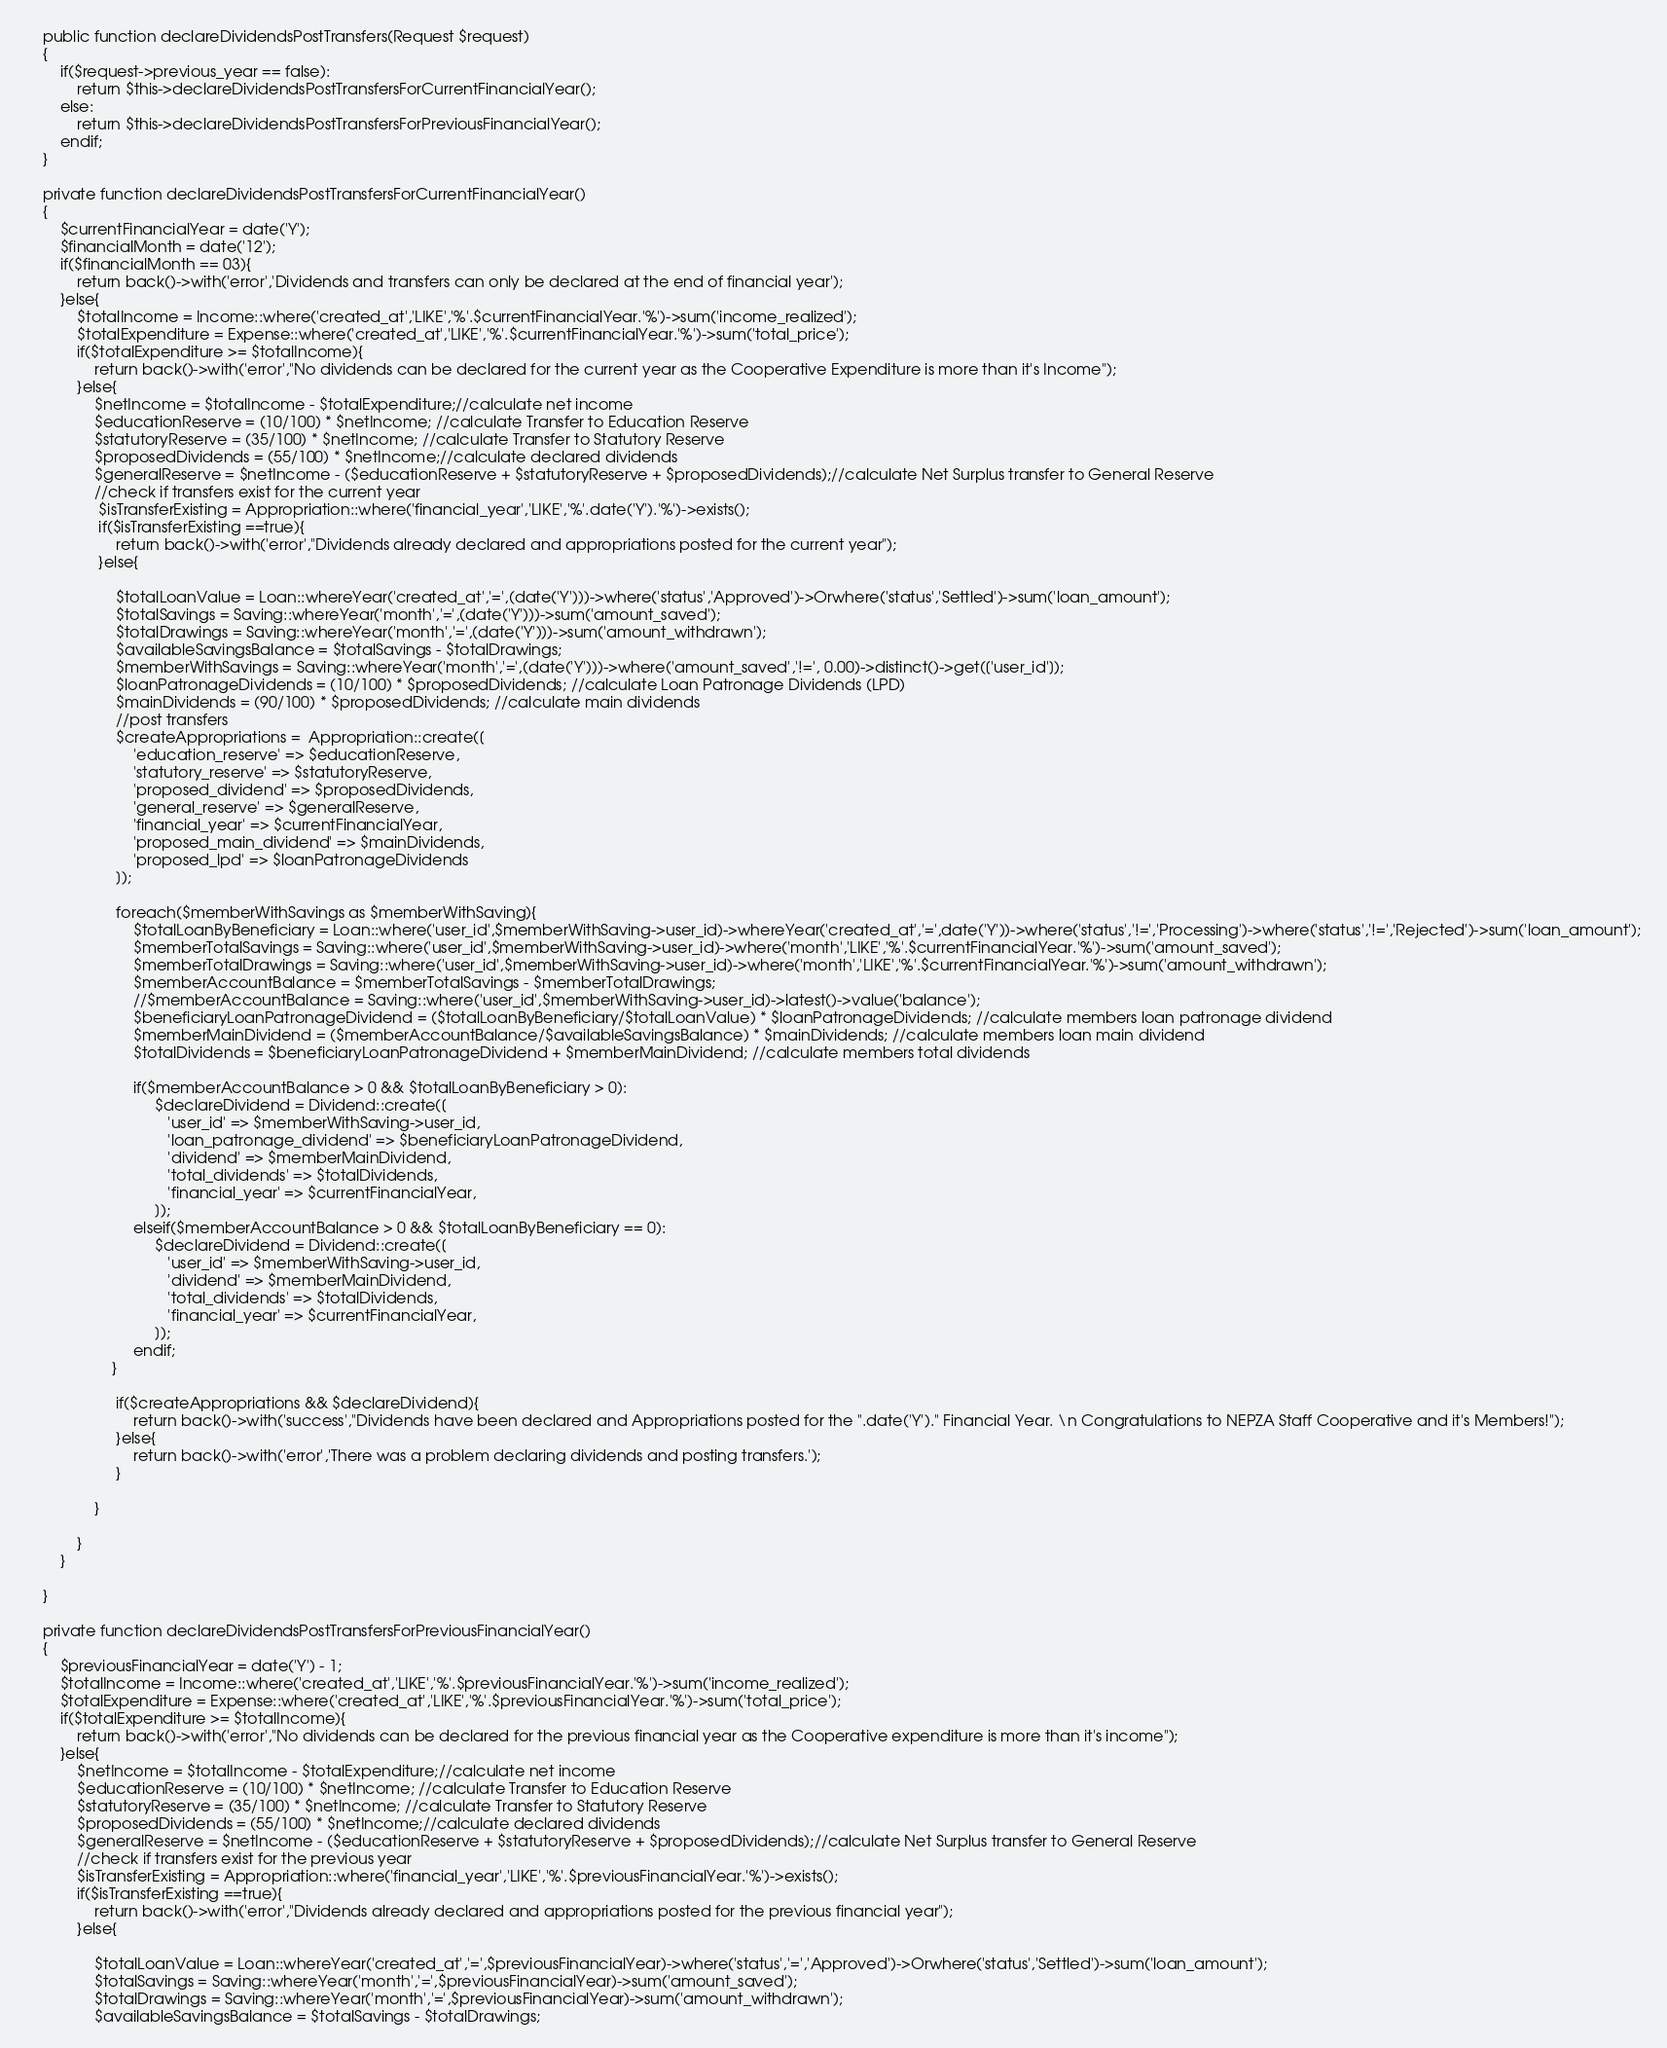<code> <loc_0><loc_0><loc_500><loc_500><_PHP_>    public function declareDividendsPostTransfers(Request $request)
    {
        if($request->previous_year == false):
            return $this->declareDividendsPostTransfersForCurrentFinancialYear();
        else:
            return $this->declareDividendsPostTransfersForPreviousFinancialYear();
        endif;
    }

    private function declareDividendsPostTransfersForCurrentFinancialYear()
    {
        $currentFinancialYear = date('Y');
        $financialMonth = date('12');
        if($financialMonth == 03){
            return back()->with('error','Dividends and transfers can only be declared at the end of financial year');
        }else{
            $totalIncome = Income::where('created_at','LIKE','%'.$currentFinancialYear.'%')->sum('income_realized');
            $totalExpenditure = Expense::where('created_at','LIKE','%'.$currentFinancialYear.'%')->sum('total_price');
            if($totalExpenditure >= $totalIncome){
                return back()->with('error',"No dividends can be declared for the current year as the Cooperative Expenditure is more than it's Income");
            }else{
                $netIncome = $totalIncome - $totalExpenditure;//calculate net income
                $educationReserve = (10/100) * $netIncome; //calculate Transfer to Education Reserve
                $statutoryReserve = (35/100) * $netIncome; //calculate Transfer to Statutory Reserve
                $proposedDividends = (55/100) * $netIncome;//calculate declared dividends
                $generalReserve = $netIncome - ($educationReserve + $statutoryReserve + $proposedDividends);//calculate Net Surplus transfer to General Reserve
                //check if transfers exist for the current year
                 $isTransferExisting = Appropriation::where('financial_year','LIKE','%'.date('Y').'%')->exists();
                 if($isTransferExisting ==true){
                     return back()->with('error',"Dividends already declared and appropriations posted for the current year");
                 }else{

                     $totalLoanValue = Loan::whereYear('created_at','=',(date('Y')))->where('status','Approved')->Orwhere('status','Settled')->sum('loan_amount');
                     $totalSavings = Saving::whereYear('month','=',(date('Y')))->sum('amount_saved');
                     $totalDrawings = Saving::whereYear('month','=',(date('Y')))->sum('amount_withdrawn');
                     $availableSavingsBalance = $totalSavings - $totalDrawings;
                     $memberWithSavings = Saving::whereYear('month','=',(date('Y')))->where('amount_saved','!=', 0.00)->distinct()->get(['user_id']);
                     $loanPatronageDividends = (10/100) * $proposedDividends; //calculate Loan Patronage Dividends (LPD)
                     $mainDividends = (90/100) * $proposedDividends; //calculate main dividends
                     //post transfers
                     $createAppropriations =  Appropriation::create([
                         'education_reserve' => $educationReserve,
                         'statutory_reserve' => $statutoryReserve,
                         'proposed_dividend' => $proposedDividends,
                         'general_reserve' => $generalReserve,
                         'financial_year' => $currentFinancialYear,
                         'proposed_main_dividend' => $mainDividends,
                         'proposed_lpd' => $loanPatronageDividends
                     ]);

                     foreach($memberWithSavings as $memberWithSaving){
                         $totalLoanByBeneficiary = Loan::where('user_id',$memberWithSaving->user_id)->whereYear('created_at','=',date('Y'))->where('status','!=','Processing')->where('status','!=','Rejected')->sum('loan_amount');
                         $memberTotalSavings = Saving::where('user_id',$memberWithSaving->user_id)->where('month','LIKE','%'.$currentFinancialYear.'%')->sum('amount_saved');
                         $memberTotalDrawings = Saving::where('user_id',$memberWithSaving->user_id)->where('month','LIKE','%'.$currentFinancialYear.'%')->sum('amount_withdrawn');
                         $memberAccountBalance = $memberTotalSavings - $memberTotalDrawings;
                         //$memberAccountBalance = Saving::where('user_id',$memberWithSaving->user_id)->latest()->value('balance');
                         $beneficiaryLoanPatronageDividend = ($totalLoanByBeneficiary/$totalLoanValue) * $loanPatronageDividends; //calculate members loan patronage dividend
                         $memberMainDividend = ($memberAccountBalance/$availableSavingsBalance) * $mainDividends; //calculate members loan main dividend
                         $totalDividends = $beneficiaryLoanPatronageDividend + $memberMainDividend; //calculate members total dividends

                         if($memberAccountBalance > 0 && $totalLoanByBeneficiary > 0):
                              $declareDividend = Dividend::create([
                                 'user_id' => $memberWithSaving->user_id,
                                 'loan_patronage_dividend' => $beneficiaryLoanPatronageDividend,
                                 'dividend' => $memberMainDividend,
                                 'total_dividends' => $totalDividends,
                                 'financial_year' => $currentFinancialYear,
                              ]);
                         elseif($memberAccountBalance > 0 && $totalLoanByBeneficiary == 0):
                              $declareDividend = Dividend::create([
                                 'user_id' => $memberWithSaving->user_id,
                                 'dividend' => $memberMainDividend,
                                 'total_dividends' => $totalDividends,
                                 'financial_year' => $currentFinancialYear,
                              ]);
                         endif;
                    }

                     if($createAppropriations && $declareDividend){
                         return back()->with('success',"Dividends have been declared and Appropriations posted for the ".date('Y')." Financial Year. \n Congratulations to NEPZA Staff Cooperative and it's Members!");
                     }else{
                         return back()->with('error','There was a problem declaring dividends and posting transfers.');
                     }

                }

            }
        }

    }

    private function declareDividendsPostTransfersForPreviousFinancialYear()
    {
        $previousFinancialYear = date('Y') - 1;
        $totalIncome = Income::where('created_at','LIKE','%'.$previousFinancialYear.'%')->sum('income_realized');
        $totalExpenditure = Expense::where('created_at','LIKE','%'.$previousFinancialYear.'%')->sum('total_price');
        if($totalExpenditure >= $totalIncome){
            return back()->with('error',"No dividends can be declared for the previous financial year as the Cooperative expenditure is more than it's income");
        }else{
            $netIncome = $totalIncome - $totalExpenditure;//calculate net income
            $educationReserve = (10/100) * $netIncome; //calculate Transfer to Education Reserve
            $statutoryReserve = (35/100) * $netIncome; //calculate Transfer to Statutory Reserve
            $proposedDividends = (55/100) * $netIncome;//calculate declared dividends
            $generalReserve = $netIncome - ($educationReserve + $statutoryReserve + $proposedDividends);//calculate Net Surplus transfer to General Reserve
            //check if transfers exist for the previous year
            $isTransferExisting = Appropriation::where('financial_year','LIKE','%'.$previousFinancialYear.'%')->exists();
            if($isTransferExisting ==true){
                return back()->with('error',"Dividends already declared and appropriations posted for the previous financial year");
            }else{

                $totalLoanValue = Loan::whereYear('created_at','=',$previousFinancialYear)->where('status','=','Approved')->Orwhere('status','Settled')->sum('loan_amount');
                $totalSavings = Saving::whereYear('month','=',$previousFinancialYear)->sum('amount_saved');
                $totalDrawings = Saving::whereYear('month','=',$previousFinancialYear)->sum('amount_withdrawn');
                $availableSavingsBalance = $totalSavings - $totalDrawings;</code> 